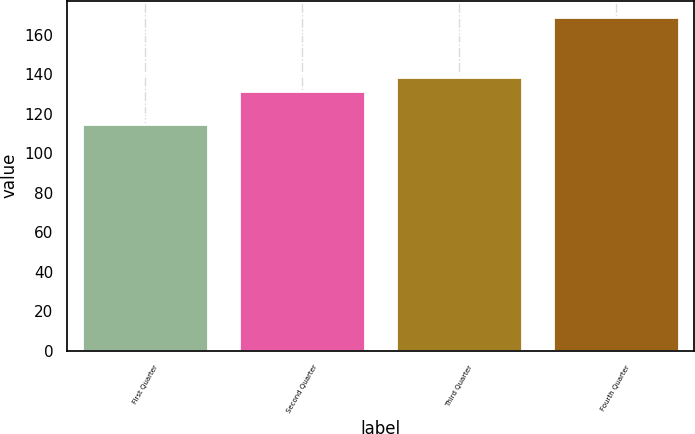Convert chart. <chart><loc_0><loc_0><loc_500><loc_500><bar_chart><fcel>First Quarter<fcel>Second Quarter<fcel>Third Quarter<fcel>Fourth Quarter<nl><fcel>114.63<fcel>131.31<fcel>138.67<fcel>168.77<nl></chart> 